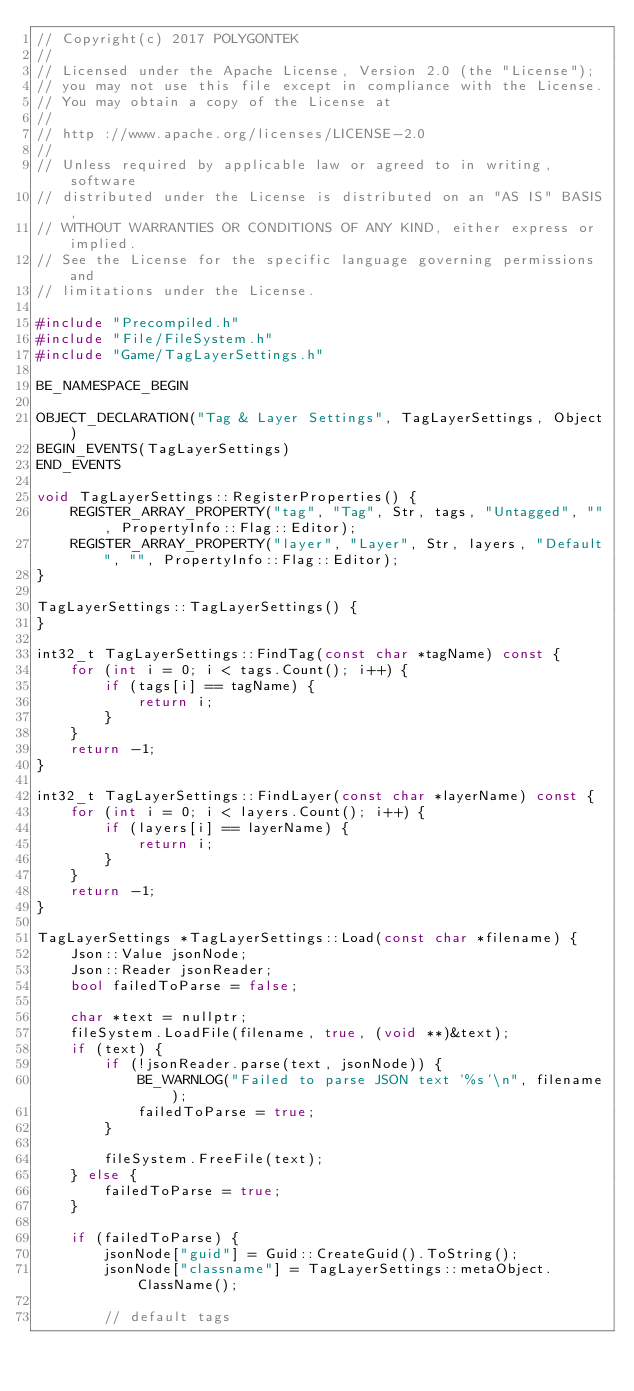Convert code to text. <code><loc_0><loc_0><loc_500><loc_500><_C++_>// Copyright(c) 2017 POLYGONTEK
// 
// Licensed under the Apache License, Version 2.0 (the "License");
// you may not use this file except in compliance with the License.
// You may obtain a copy of the License at
// 
// http ://www.apache.org/licenses/LICENSE-2.0
// 
// Unless required by applicable law or agreed to in writing, software
// distributed under the License is distributed on an "AS IS" BASIS,
// WITHOUT WARRANTIES OR CONDITIONS OF ANY KIND, either express or implied.
// See the License for the specific language governing permissions and
// limitations under the License.

#include "Precompiled.h"
#include "File/FileSystem.h"
#include "Game/TagLayerSettings.h"

BE_NAMESPACE_BEGIN

OBJECT_DECLARATION("Tag & Layer Settings", TagLayerSettings, Object)
BEGIN_EVENTS(TagLayerSettings)
END_EVENTS

void TagLayerSettings::RegisterProperties() {
    REGISTER_ARRAY_PROPERTY("tag", "Tag", Str, tags, "Untagged", "", PropertyInfo::Flag::Editor);
    REGISTER_ARRAY_PROPERTY("layer", "Layer", Str, layers, "Default", "", PropertyInfo::Flag::Editor);
}

TagLayerSettings::TagLayerSettings() {
}

int32_t TagLayerSettings::FindTag(const char *tagName) const {
    for (int i = 0; i < tags.Count(); i++) {
        if (tags[i] == tagName) {
            return i;
        }
    }
    return -1;
}

int32_t TagLayerSettings::FindLayer(const char *layerName) const {
    for (int i = 0; i < layers.Count(); i++) {
        if (layers[i] == layerName) {
            return i;
        }
    }
    return -1;
}

TagLayerSettings *TagLayerSettings::Load(const char *filename) {
    Json::Value jsonNode;
    Json::Reader jsonReader;
    bool failedToParse = false;

    char *text = nullptr;
    fileSystem.LoadFile(filename, true, (void **)&text);
    if (text) {
        if (!jsonReader.parse(text, jsonNode)) {
            BE_WARNLOG("Failed to parse JSON text '%s'\n", filename);
            failedToParse = true;
        }

        fileSystem.FreeFile(text);
    } else {
        failedToParse = true;
    }

    if (failedToParse) {
        jsonNode["guid"] = Guid::CreateGuid().ToString();
        jsonNode["classname"] = TagLayerSettings::metaObject.ClassName();

        // default tags</code> 